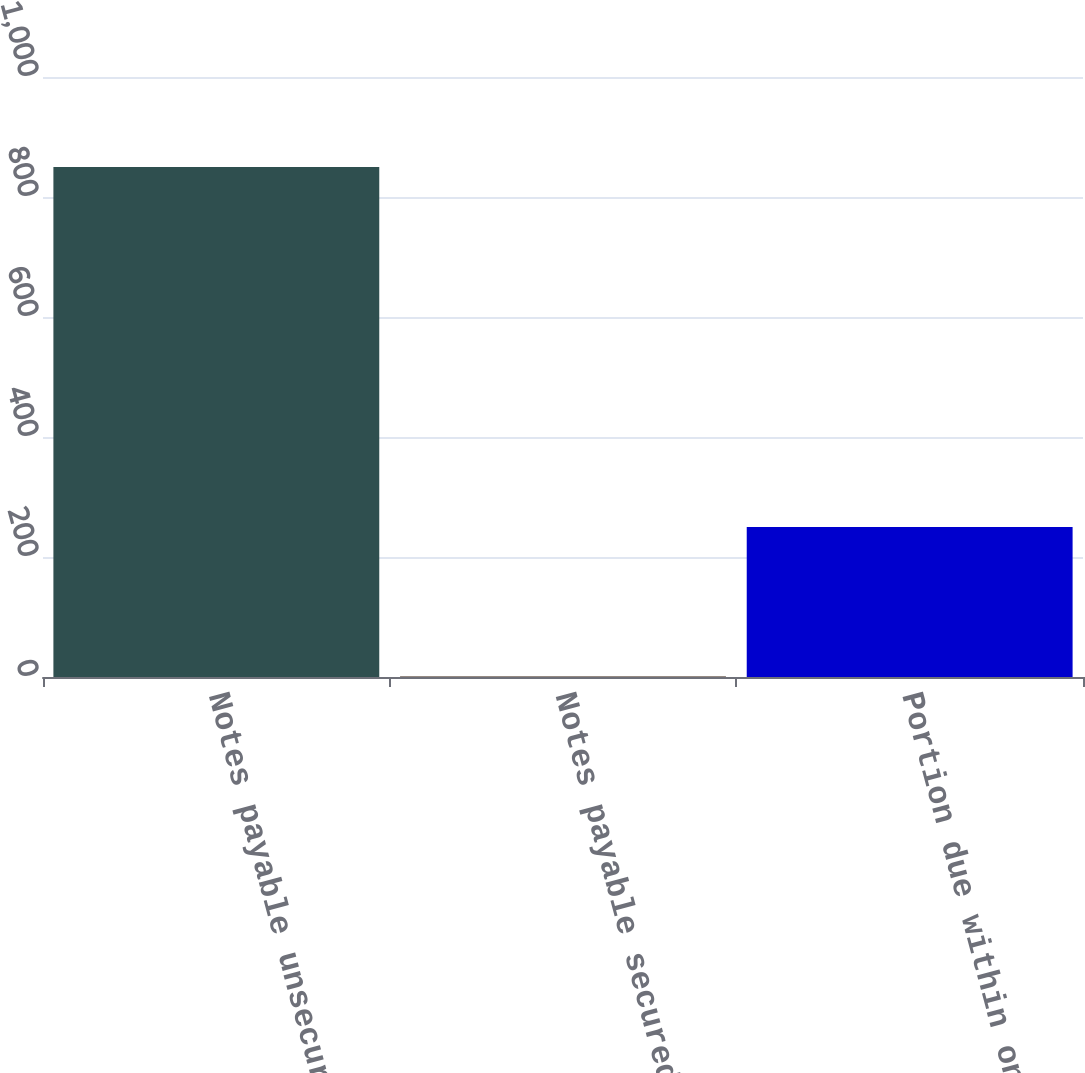Convert chart to OTSL. <chart><loc_0><loc_0><loc_500><loc_500><bar_chart><fcel>Notes payable unsecured<fcel>Notes payable secured weighted<fcel>Portion due within one year<nl><fcel>850<fcel>1<fcel>250<nl></chart> 